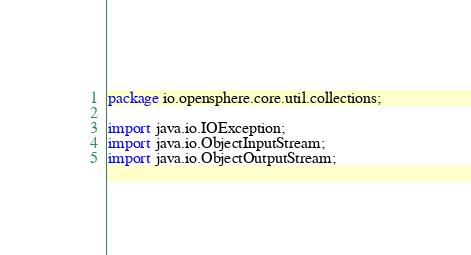<code> <loc_0><loc_0><loc_500><loc_500><_Java_>package io.opensphere.core.util.collections;

import java.io.IOException;
import java.io.ObjectInputStream;
import java.io.ObjectOutputStream;</code> 